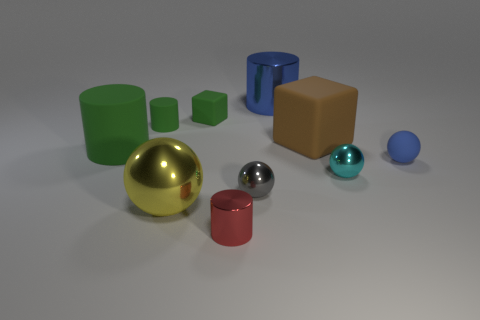Are there any objects that stand out in terms of color? Yes, the red cylinder stands out due to its vibrant hue, which contrasts more sharply with the muted tones of the other objects and the background. Is there a color theme or pattern among the objects? The objects seem to be presented in a variety of colors without a specific theme or pattern, although the colors chosen are primarily primaries and secondaries, which create a visually interesting assortment. 